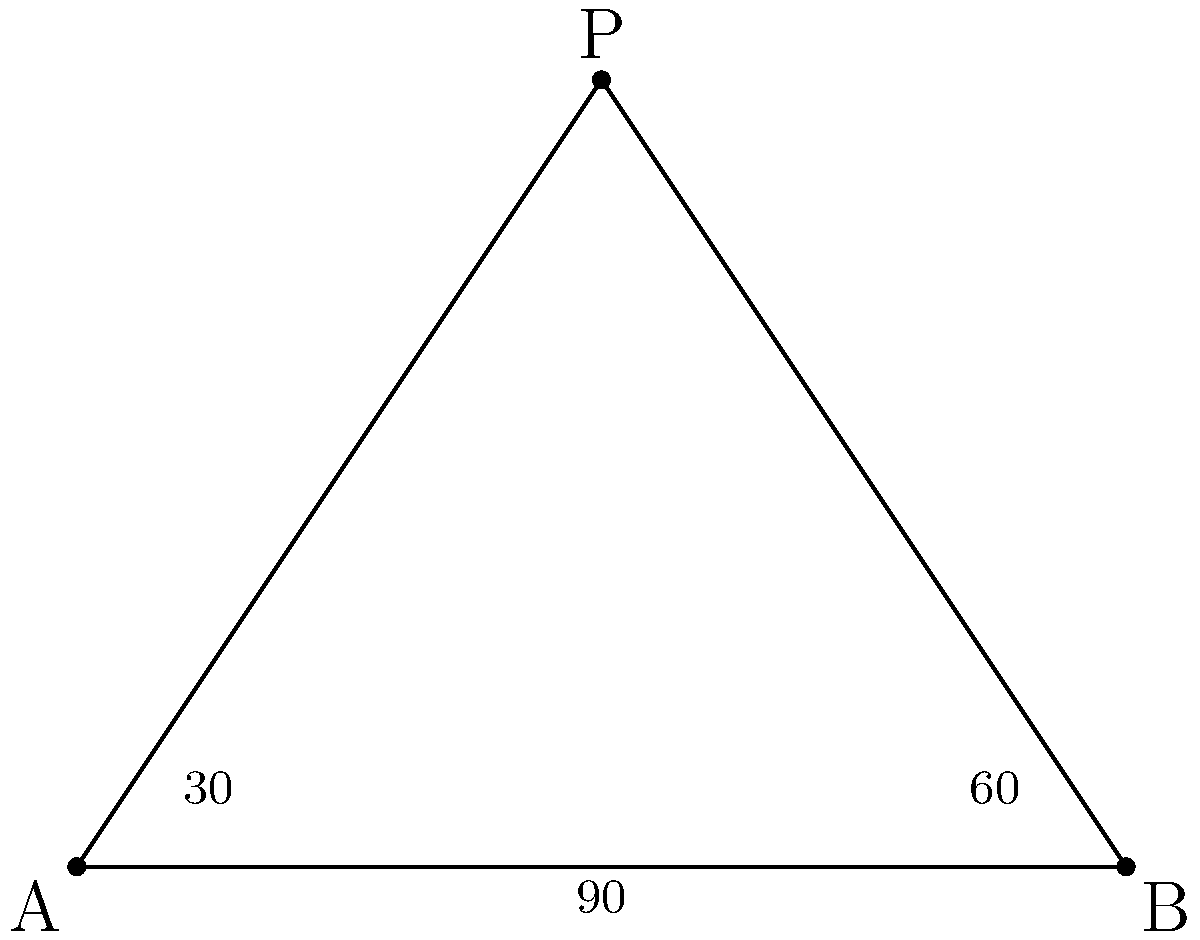During a religious ceremony, three people are standing at points A, B, and P, forming a triangle. The angle at A is 30°, and the angle at B is 60°. What is the measure of angle APB? Let's approach this step-by-step:

1) First, recall that the sum of angles in a triangle is always 180°.

2) We're given two angles in the triangle:
   - Angle at A = 30°
   - Angle at B = 60°

3) Let's call the angle at P (which we're looking for) x°.

4) We can set up an equation based on the fact that all angles in a triangle sum to 180°:
   
   $30° + 60° + x° = 180°$

5) Simplify:
   
   $90° + x° = 180°$

6) Subtract 90° from both sides:
   
   $x° = 180° - 90° = 90°$

7) Therefore, the angle at P (angle APB) is 90°.

8) This also makes sense geometrically, as we can see that AP and BP form a right angle at P in the diagram.
Answer: 90° 